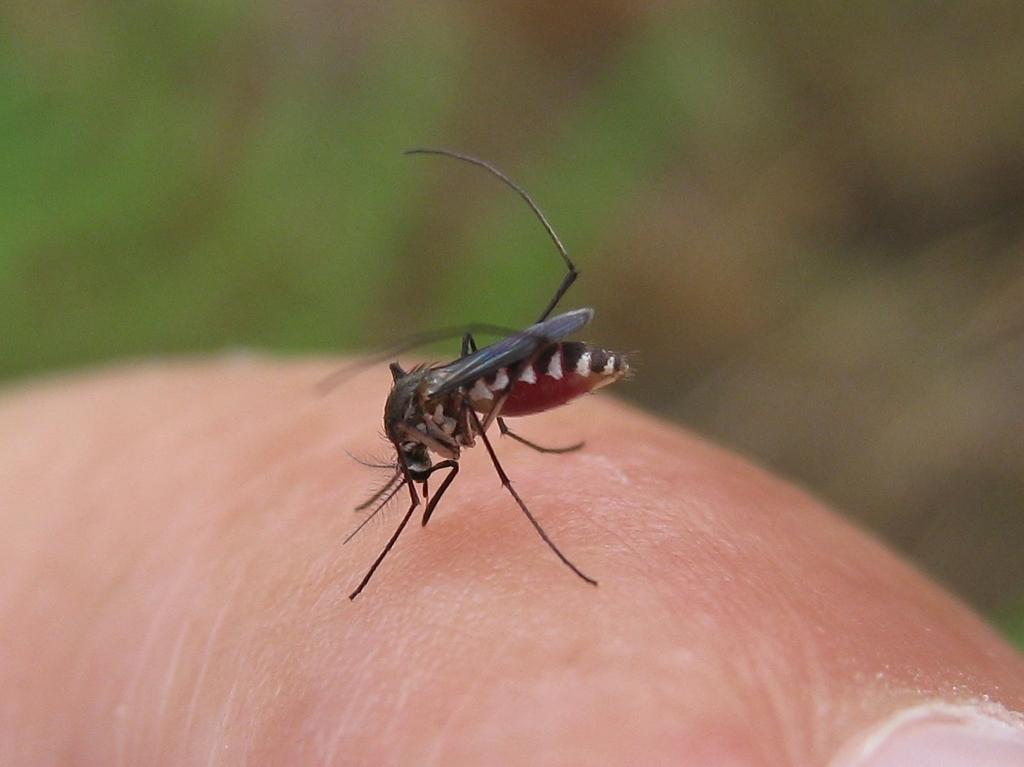How would you summarize this image in a sentence or two? In this picture I can see a mosquito in the middle, at the bottom it looks like the skin of a human. 